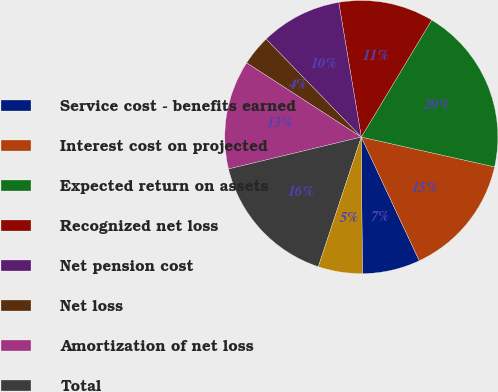<chart> <loc_0><loc_0><loc_500><loc_500><pie_chart><fcel>Service cost - benefits earned<fcel>Interest cost on projected<fcel>Expected return on assets<fcel>Recognized net loss<fcel>Net pension cost<fcel>Net loss<fcel>Amortization of net loss<fcel>Total<fcel>Total recognized as net<nl><fcel>6.85%<fcel>14.52%<fcel>19.88%<fcel>11.26%<fcel>9.63%<fcel>3.59%<fcel>12.89%<fcel>16.15%<fcel>5.22%<nl></chart> 